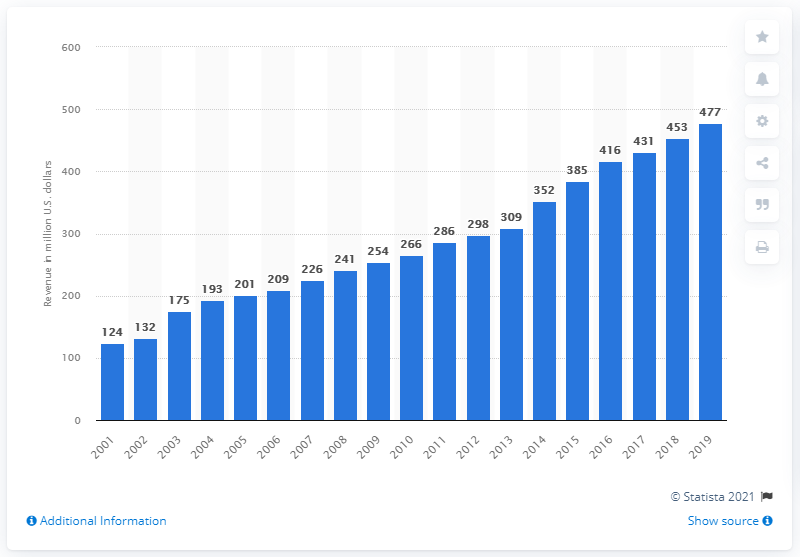Point out several critical features in this image. In 2019, the Chicago Bears generated a revenue of 477 million dollars. In the year 2001, the Chicago Bears became a franchise of the National Football League. 